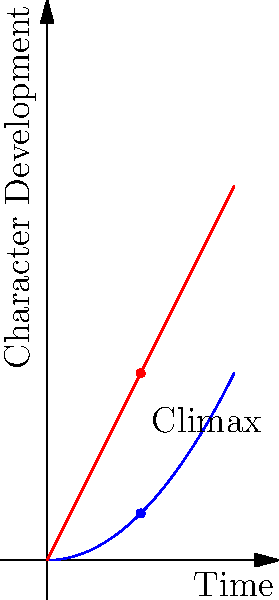In the graph representing character development arcs in a film narrative, two characters (A and B) are shown. Character A follows a parabolic arc described by the function $f(x) = 0.5x^2$, while Character B follows a linear arc described by $g(x) = 2x$. At what point in the narrative do these characters experience equal development, and what does this intersection signify in terms of narrative structure? To find the intersection point of the two character arcs, we need to solve the equation:

$$f(x) = g(x)$$
$$0.5x^2 = 2x$$

Rearranging the equation:
$$0.5x^2 - 2x = 0$$
$$x(0.5x - 2) = 0$$

Solving this equation:
$$x = 0$$ or $$0.5x - 2 = 0$$
$$x = 4$$

Since the graph only shows the interval [0,2], the intersection point occurs at x = 0.

Step-by-step analysis:
1. At x = 0, both characters start at the same level of development (the origin).
2. Character B (linear arc) initially develops faster than Character A (parabolic arc).
3. Character A's development accelerates over time, while Character B's remains constant.
4. The climax of the film occurs at x = 1, where both characters have experienced significant development.
5. After the climax, Character A's development continues to accelerate, potentially surpassing Character B.

This intersection at the origin signifies the starting point of the narrative, where both characters are at the same level of development. The diverging arcs represent their different growth trajectories throughout the film, with Character A having a slower start but potentially more profound long-term development, while Character B experiences steady, consistent growth.
Answer: The characters experience equal development at the origin (0,0), signifying the narrative's starting point. 